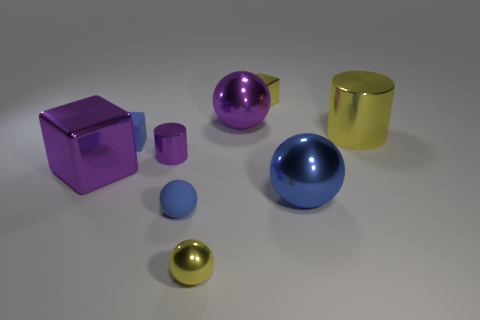What could be the function of these objects and how might they be used together? These objects appear to be geometric models typically used for educational purposes or as part of a set for teaching geometry and physics. For instance, one could use the different materials to discuss density and buoyancy, and the varying shapes could be handy for lessons on volume and surface area. 